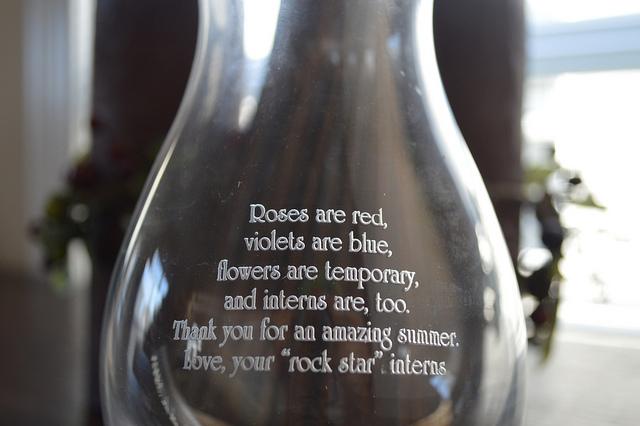Who gave this vase?
Give a very brief answer. Interns. What color are the roses?
Keep it brief. Red. What writing style is on the vase?
Concise answer only. Etched. 